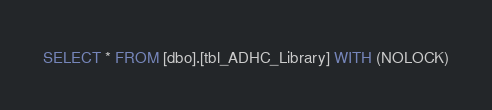<code> <loc_0><loc_0><loc_500><loc_500><_SQL_>SELECT * FROM [dbo].[tbl_ADHC_Library] WITH (NOLOCK)</code> 